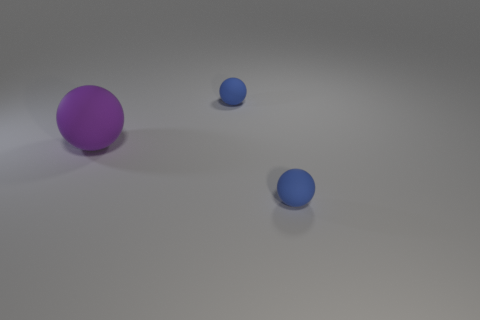What can you tell about the texture of the spheres? The texture of the spheres seems to be smooth and reflective, indicating they are likely made of a rubbery or plastic material. 